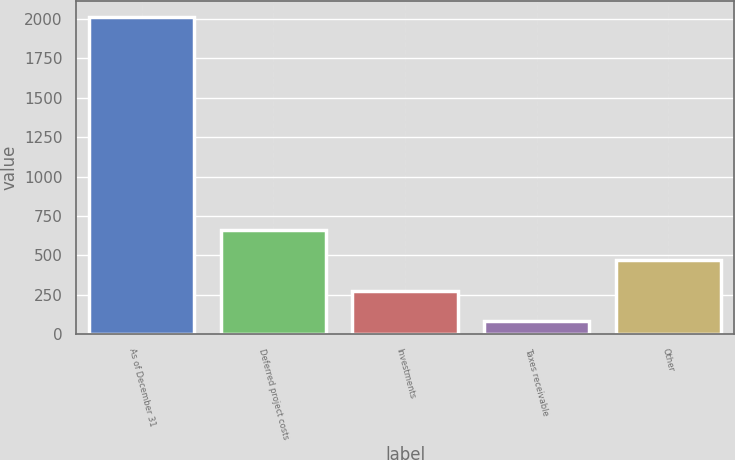Convert chart. <chart><loc_0><loc_0><loc_500><loc_500><bar_chart><fcel>As of December 31<fcel>Deferred project costs<fcel>Investments<fcel>Taxes receivable<fcel>Other<nl><fcel>2015<fcel>661.9<fcel>275.3<fcel>82<fcel>468.6<nl></chart> 